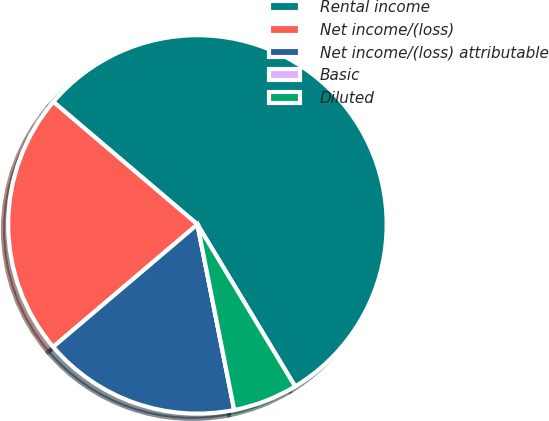<chart> <loc_0><loc_0><loc_500><loc_500><pie_chart><fcel>Rental income<fcel>Net income/(loss)<fcel>Net income/(loss) attributable<fcel>Basic<fcel>Diluted<nl><fcel>55.15%<fcel>22.42%<fcel>16.91%<fcel>0.0%<fcel>5.52%<nl></chart> 